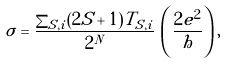Convert formula to latex. <formula><loc_0><loc_0><loc_500><loc_500>\sigma = \frac { \sum _ { S , i } ( 2 S + 1 ) T _ { S , i } } { 2 ^ { N } } \, \left ( \frac { 2 e ^ { 2 } } { h } \right ) ,</formula> 